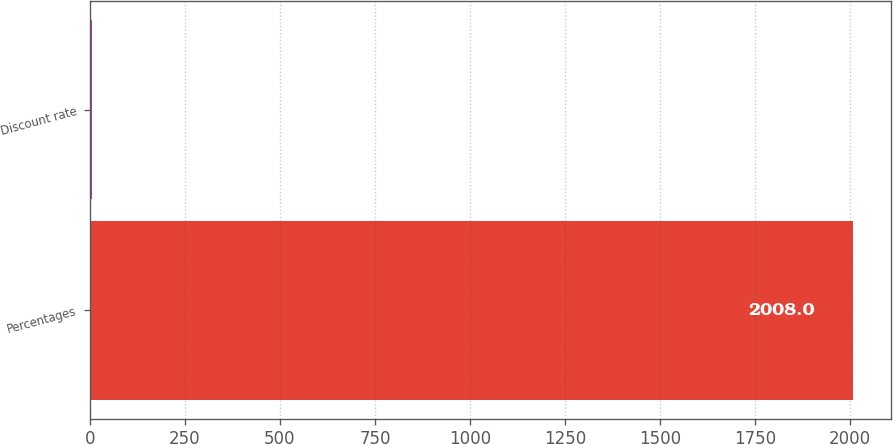<chart> <loc_0><loc_0><loc_500><loc_500><bar_chart><fcel>Percentages<fcel>Discount rate<nl><fcel>2008<fcel>6.5<nl></chart> 